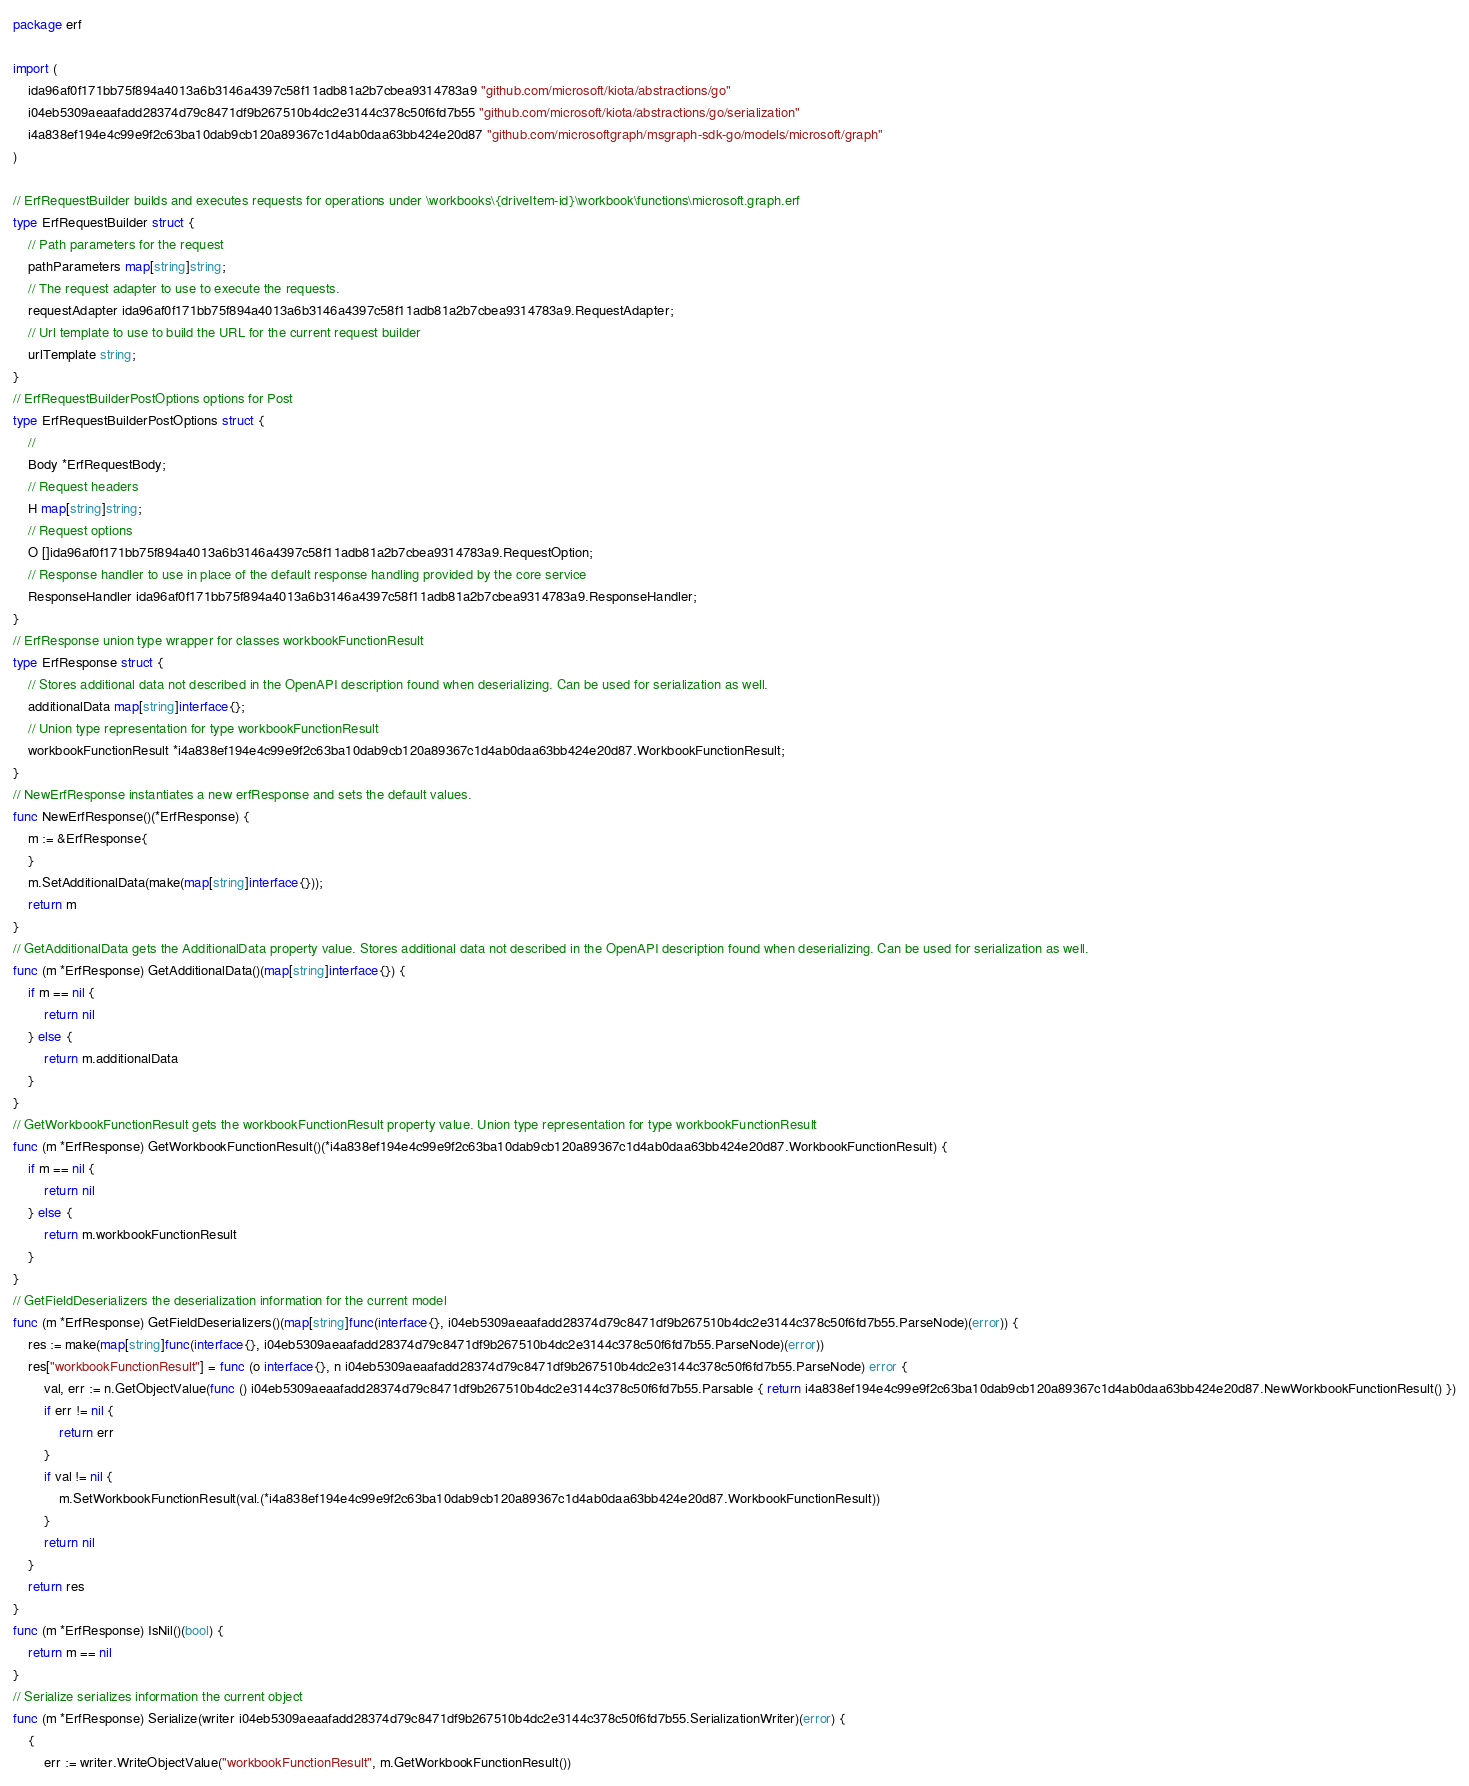Convert code to text. <code><loc_0><loc_0><loc_500><loc_500><_Go_>package erf

import (
    ida96af0f171bb75f894a4013a6b3146a4397c58f11adb81a2b7cbea9314783a9 "github.com/microsoft/kiota/abstractions/go"
    i04eb5309aeaafadd28374d79c8471df9b267510b4dc2e3144c378c50f6fd7b55 "github.com/microsoft/kiota/abstractions/go/serialization"
    i4a838ef194e4c99e9f2c63ba10dab9cb120a89367c1d4ab0daa63bb424e20d87 "github.com/microsoftgraph/msgraph-sdk-go/models/microsoft/graph"
)

// ErfRequestBuilder builds and executes requests for operations under \workbooks\{driveItem-id}\workbook\functions\microsoft.graph.erf
type ErfRequestBuilder struct {
    // Path parameters for the request
    pathParameters map[string]string;
    // The request adapter to use to execute the requests.
    requestAdapter ida96af0f171bb75f894a4013a6b3146a4397c58f11adb81a2b7cbea9314783a9.RequestAdapter;
    // Url template to use to build the URL for the current request builder
    urlTemplate string;
}
// ErfRequestBuilderPostOptions options for Post
type ErfRequestBuilderPostOptions struct {
    // 
    Body *ErfRequestBody;
    // Request headers
    H map[string]string;
    // Request options
    O []ida96af0f171bb75f894a4013a6b3146a4397c58f11adb81a2b7cbea9314783a9.RequestOption;
    // Response handler to use in place of the default response handling provided by the core service
    ResponseHandler ida96af0f171bb75f894a4013a6b3146a4397c58f11adb81a2b7cbea9314783a9.ResponseHandler;
}
// ErfResponse union type wrapper for classes workbookFunctionResult
type ErfResponse struct {
    // Stores additional data not described in the OpenAPI description found when deserializing. Can be used for serialization as well.
    additionalData map[string]interface{};
    // Union type representation for type workbookFunctionResult
    workbookFunctionResult *i4a838ef194e4c99e9f2c63ba10dab9cb120a89367c1d4ab0daa63bb424e20d87.WorkbookFunctionResult;
}
// NewErfResponse instantiates a new erfResponse and sets the default values.
func NewErfResponse()(*ErfResponse) {
    m := &ErfResponse{
    }
    m.SetAdditionalData(make(map[string]interface{}));
    return m
}
// GetAdditionalData gets the AdditionalData property value. Stores additional data not described in the OpenAPI description found when deserializing. Can be used for serialization as well.
func (m *ErfResponse) GetAdditionalData()(map[string]interface{}) {
    if m == nil {
        return nil
    } else {
        return m.additionalData
    }
}
// GetWorkbookFunctionResult gets the workbookFunctionResult property value. Union type representation for type workbookFunctionResult
func (m *ErfResponse) GetWorkbookFunctionResult()(*i4a838ef194e4c99e9f2c63ba10dab9cb120a89367c1d4ab0daa63bb424e20d87.WorkbookFunctionResult) {
    if m == nil {
        return nil
    } else {
        return m.workbookFunctionResult
    }
}
// GetFieldDeserializers the deserialization information for the current model
func (m *ErfResponse) GetFieldDeserializers()(map[string]func(interface{}, i04eb5309aeaafadd28374d79c8471df9b267510b4dc2e3144c378c50f6fd7b55.ParseNode)(error)) {
    res := make(map[string]func(interface{}, i04eb5309aeaafadd28374d79c8471df9b267510b4dc2e3144c378c50f6fd7b55.ParseNode)(error))
    res["workbookFunctionResult"] = func (o interface{}, n i04eb5309aeaafadd28374d79c8471df9b267510b4dc2e3144c378c50f6fd7b55.ParseNode) error {
        val, err := n.GetObjectValue(func () i04eb5309aeaafadd28374d79c8471df9b267510b4dc2e3144c378c50f6fd7b55.Parsable { return i4a838ef194e4c99e9f2c63ba10dab9cb120a89367c1d4ab0daa63bb424e20d87.NewWorkbookFunctionResult() })
        if err != nil {
            return err
        }
        if val != nil {
            m.SetWorkbookFunctionResult(val.(*i4a838ef194e4c99e9f2c63ba10dab9cb120a89367c1d4ab0daa63bb424e20d87.WorkbookFunctionResult))
        }
        return nil
    }
    return res
}
func (m *ErfResponse) IsNil()(bool) {
    return m == nil
}
// Serialize serializes information the current object
func (m *ErfResponse) Serialize(writer i04eb5309aeaafadd28374d79c8471df9b267510b4dc2e3144c378c50f6fd7b55.SerializationWriter)(error) {
    {
        err := writer.WriteObjectValue("workbookFunctionResult", m.GetWorkbookFunctionResult())</code> 